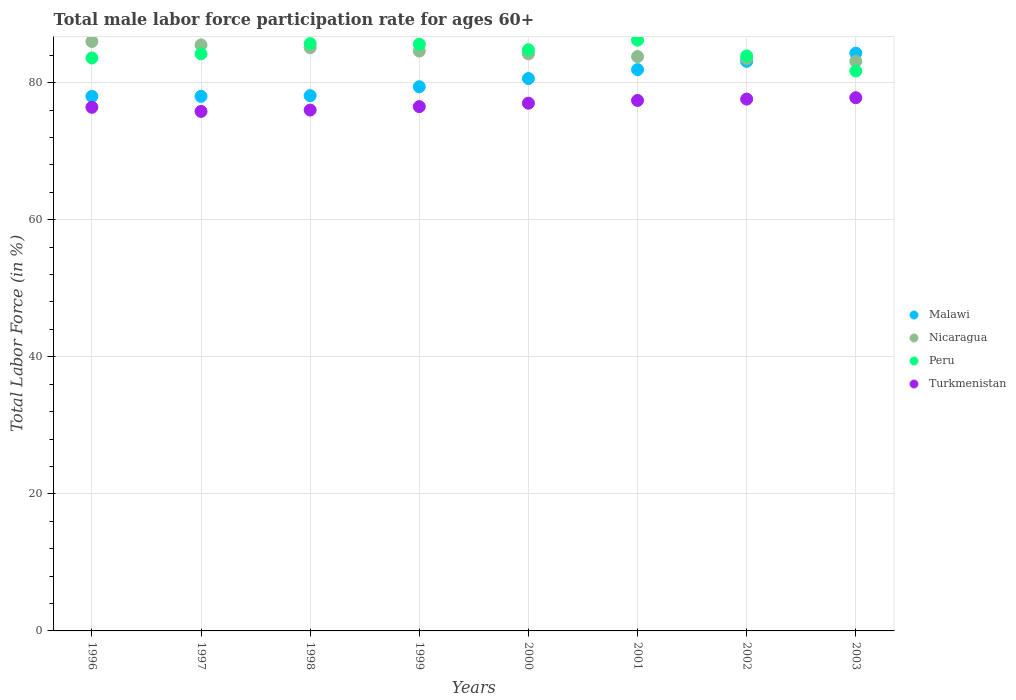How many different coloured dotlines are there?
Ensure brevity in your answer.  4. What is the male labor force participation rate in Peru in 2002?
Keep it short and to the point. 83.9. Across all years, what is the maximum male labor force participation rate in Peru?
Your answer should be compact. 86.2. Across all years, what is the minimum male labor force participation rate in Turkmenistan?
Ensure brevity in your answer.  75.8. What is the total male labor force participation rate in Malawi in the graph?
Your answer should be compact. 643.4. What is the difference between the male labor force participation rate in Malawi in 1999 and that in 2001?
Your response must be concise. -2.5. What is the difference between the male labor force participation rate in Malawi in 2003 and the male labor force participation rate in Turkmenistan in 1999?
Provide a short and direct response. 7.8. What is the average male labor force participation rate in Peru per year?
Offer a terse response. 84.46. In the year 1998, what is the difference between the male labor force participation rate in Turkmenistan and male labor force participation rate in Nicaragua?
Provide a short and direct response. -9.1. In how many years, is the male labor force participation rate in Malawi greater than 32 %?
Your answer should be compact. 8. What is the ratio of the male labor force participation rate in Malawi in 1998 to that in 2001?
Ensure brevity in your answer.  0.95. What is the difference between the highest and the second highest male labor force participation rate in Turkmenistan?
Give a very brief answer. 0.2. What is the difference between the highest and the lowest male labor force participation rate in Malawi?
Give a very brief answer. 6.3. In how many years, is the male labor force participation rate in Malawi greater than the average male labor force participation rate in Malawi taken over all years?
Offer a terse response. 4. Is the sum of the male labor force participation rate in Peru in 2000 and 2002 greater than the maximum male labor force participation rate in Nicaragua across all years?
Your response must be concise. Yes. Is it the case that in every year, the sum of the male labor force participation rate in Malawi and male labor force participation rate in Peru  is greater than the male labor force participation rate in Turkmenistan?
Ensure brevity in your answer.  Yes. Is the male labor force participation rate in Turkmenistan strictly less than the male labor force participation rate in Malawi over the years?
Your answer should be very brief. Yes. What is the difference between two consecutive major ticks on the Y-axis?
Your answer should be very brief. 20. Are the values on the major ticks of Y-axis written in scientific E-notation?
Your answer should be compact. No. Does the graph contain any zero values?
Ensure brevity in your answer.  No. Where does the legend appear in the graph?
Make the answer very short. Center right. How many legend labels are there?
Ensure brevity in your answer.  4. What is the title of the graph?
Make the answer very short. Total male labor force participation rate for ages 60+. Does "Luxembourg" appear as one of the legend labels in the graph?
Provide a succinct answer. No. What is the Total Labor Force (in %) of Malawi in 1996?
Make the answer very short. 78. What is the Total Labor Force (in %) of Peru in 1996?
Offer a terse response. 83.6. What is the Total Labor Force (in %) of Turkmenistan in 1996?
Make the answer very short. 76.4. What is the Total Labor Force (in %) in Nicaragua in 1997?
Your answer should be compact. 85.5. What is the Total Labor Force (in %) in Peru in 1997?
Ensure brevity in your answer.  84.2. What is the Total Labor Force (in %) of Turkmenistan in 1997?
Provide a succinct answer. 75.8. What is the Total Labor Force (in %) in Malawi in 1998?
Ensure brevity in your answer.  78.1. What is the Total Labor Force (in %) of Nicaragua in 1998?
Make the answer very short. 85.1. What is the Total Labor Force (in %) of Peru in 1998?
Offer a very short reply. 85.7. What is the Total Labor Force (in %) of Malawi in 1999?
Provide a succinct answer. 79.4. What is the Total Labor Force (in %) of Nicaragua in 1999?
Make the answer very short. 84.6. What is the Total Labor Force (in %) in Peru in 1999?
Provide a short and direct response. 85.6. What is the Total Labor Force (in %) of Turkmenistan in 1999?
Ensure brevity in your answer.  76.5. What is the Total Labor Force (in %) of Malawi in 2000?
Keep it short and to the point. 80.6. What is the Total Labor Force (in %) in Nicaragua in 2000?
Keep it short and to the point. 84.2. What is the Total Labor Force (in %) of Peru in 2000?
Give a very brief answer. 84.8. What is the Total Labor Force (in %) of Malawi in 2001?
Provide a succinct answer. 81.9. What is the Total Labor Force (in %) in Nicaragua in 2001?
Keep it short and to the point. 83.8. What is the Total Labor Force (in %) in Peru in 2001?
Offer a terse response. 86.2. What is the Total Labor Force (in %) of Turkmenistan in 2001?
Your response must be concise. 77.4. What is the Total Labor Force (in %) in Malawi in 2002?
Offer a very short reply. 83.1. What is the Total Labor Force (in %) in Nicaragua in 2002?
Give a very brief answer. 83.5. What is the Total Labor Force (in %) in Peru in 2002?
Provide a short and direct response. 83.9. What is the Total Labor Force (in %) of Turkmenistan in 2002?
Provide a short and direct response. 77.6. What is the Total Labor Force (in %) of Malawi in 2003?
Give a very brief answer. 84.3. What is the Total Labor Force (in %) of Nicaragua in 2003?
Ensure brevity in your answer.  83.1. What is the Total Labor Force (in %) of Peru in 2003?
Provide a succinct answer. 81.7. What is the Total Labor Force (in %) in Turkmenistan in 2003?
Your response must be concise. 77.8. Across all years, what is the maximum Total Labor Force (in %) in Malawi?
Offer a terse response. 84.3. Across all years, what is the maximum Total Labor Force (in %) in Nicaragua?
Offer a very short reply. 86. Across all years, what is the maximum Total Labor Force (in %) in Peru?
Your answer should be very brief. 86.2. Across all years, what is the maximum Total Labor Force (in %) of Turkmenistan?
Your response must be concise. 77.8. Across all years, what is the minimum Total Labor Force (in %) in Malawi?
Give a very brief answer. 78. Across all years, what is the minimum Total Labor Force (in %) in Nicaragua?
Make the answer very short. 83.1. Across all years, what is the minimum Total Labor Force (in %) of Peru?
Your answer should be compact. 81.7. Across all years, what is the minimum Total Labor Force (in %) in Turkmenistan?
Give a very brief answer. 75.8. What is the total Total Labor Force (in %) of Malawi in the graph?
Your response must be concise. 643.4. What is the total Total Labor Force (in %) of Nicaragua in the graph?
Give a very brief answer. 675.8. What is the total Total Labor Force (in %) in Peru in the graph?
Your response must be concise. 675.7. What is the total Total Labor Force (in %) in Turkmenistan in the graph?
Your response must be concise. 614.5. What is the difference between the Total Labor Force (in %) in Malawi in 1996 and that in 1998?
Ensure brevity in your answer.  -0.1. What is the difference between the Total Labor Force (in %) of Nicaragua in 1996 and that in 1998?
Your answer should be compact. 0.9. What is the difference between the Total Labor Force (in %) in Peru in 1996 and that in 1998?
Your response must be concise. -2.1. What is the difference between the Total Labor Force (in %) in Turkmenistan in 1996 and that in 1998?
Make the answer very short. 0.4. What is the difference between the Total Labor Force (in %) of Peru in 1996 and that in 1999?
Provide a succinct answer. -2. What is the difference between the Total Labor Force (in %) in Malawi in 1996 and that in 2000?
Provide a short and direct response. -2.6. What is the difference between the Total Labor Force (in %) of Nicaragua in 1996 and that in 2000?
Provide a succinct answer. 1.8. What is the difference between the Total Labor Force (in %) of Malawi in 1996 and that in 2001?
Give a very brief answer. -3.9. What is the difference between the Total Labor Force (in %) in Nicaragua in 1996 and that in 2001?
Your answer should be very brief. 2.2. What is the difference between the Total Labor Force (in %) of Peru in 1996 and that in 2001?
Provide a short and direct response. -2.6. What is the difference between the Total Labor Force (in %) in Malawi in 1996 and that in 2002?
Provide a short and direct response. -5.1. What is the difference between the Total Labor Force (in %) of Nicaragua in 1996 and that in 2002?
Make the answer very short. 2.5. What is the difference between the Total Labor Force (in %) in Malawi in 1996 and that in 2003?
Give a very brief answer. -6.3. What is the difference between the Total Labor Force (in %) of Peru in 1996 and that in 2003?
Your response must be concise. 1.9. What is the difference between the Total Labor Force (in %) in Turkmenistan in 1996 and that in 2003?
Your answer should be compact. -1.4. What is the difference between the Total Labor Force (in %) of Malawi in 1997 and that in 1998?
Offer a terse response. -0.1. What is the difference between the Total Labor Force (in %) of Nicaragua in 1997 and that in 1998?
Your answer should be very brief. 0.4. What is the difference between the Total Labor Force (in %) in Malawi in 1997 and that in 1999?
Ensure brevity in your answer.  -1.4. What is the difference between the Total Labor Force (in %) of Turkmenistan in 1997 and that in 1999?
Offer a very short reply. -0.7. What is the difference between the Total Labor Force (in %) in Peru in 1997 and that in 2000?
Provide a short and direct response. -0.6. What is the difference between the Total Labor Force (in %) of Malawi in 1997 and that in 2001?
Give a very brief answer. -3.9. What is the difference between the Total Labor Force (in %) of Turkmenistan in 1997 and that in 2001?
Offer a terse response. -1.6. What is the difference between the Total Labor Force (in %) in Malawi in 1997 and that in 2002?
Provide a short and direct response. -5.1. What is the difference between the Total Labor Force (in %) of Nicaragua in 1997 and that in 2002?
Your answer should be compact. 2. What is the difference between the Total Labor Force (in %) in Turkmenistan in 1997 and that in 2002?
Offer a terse response. -1.8. What is the difference between the Total Labor Force (in %) of Peru in 1997 and that in 2003?
Your answer should be compact. 2.5. What is the difference between the Total Labor Force (in %) of Malawi in 1998 and that in 1999?
Your response must be concise. -1.3. What is the difference between the Total Labor Force (in %) in Turkmenistan in 1998 and that in 1999?
Your answer should be compact. -0.5. What is the difference between the Total Labor Force (in %) of Malawi in 1998 and that in 2000?
Ensure brevity in your answer.  -2.5. What is the difference between the Total Labor Force (in %) of Nicaragua in 1998 and that in 2000?
Provide a succinct answer. 0.9. What is the difference between the Total Labor Force (in %) of Peru in 1998 and that in 2000?
Ensure brevity in your answer.  0.9. What is the difference between the Total Labor Force (in %) of Turkmenistan in 1998 and that in 2000?
Offer a very short reply. -1. What is the difference between the Total Labor Force (in %) in Nicaragua in 1998 and that in 2001?
Your answer should be very brief. 1.3. What is the difference between the Total Labor Force (in %) in Peru in 1998 and that in 2001?
Offer a very short reply. -0.5. What is the difference between the Total Labor Force (in %) in Nicaragua in 1998 and that in 2002?
Ensure brevity in your answer.  1.6. What is the difference between the Total Labor Force (in %) of Turkmenistan in 1998 and that in 2002?
Offer a terse response. -1.6. What is the difference between the Total Labor Force (in %) in Nicaragua in 1998 and that in 2003?
Give a very brief answer. 2. What is the difference between the Total Labor Force (in %) of Turkmenistan in 1998 and that in 2003?
Make the answer very short. -1.8. What is the difference between the Total Labor Force (in %) of Malawi in 1999 and that in 2000?
Make the answer very short. -1.2. What is the difference between the Total Labor Force (in %) in Peru in 1999 and that in 2000?
Ensure brevity in your answer.  0.8. What is the difference between the Total Labor Force (in %) in Malawi in 1999 and that in 2001?
Offer a very short reply. -2.5. What is the difference between the Total Labor Force (in %) of Malawi in 1999 and that in 2002?
Your response must be concise. -3.7. What is the difference between the Total Labor Force (in %) of Nicaragua in 1999 and that in 2002?
Your answer should be very brief. 1.1. What is the difference between the Total Labor Force (in %) in Peru in 1999 and that in 2002?
Give a very brief answer. 1.7. What is the difference between the Total Labor Force (in %) in Turkmenistan in 1999 and that in 2002?
Your answer should be very brief. -1.1. What is the difference between the Total Labor Force (in %) of Malawi in 1999 and that in 2003?
Ensure brevity in your answer.  -4.9. What is the difference between the Total Labor Force (in %) in Peru in 1999 and that in 2003?
Keep it short and to the point. 3.9. What is the difference between the Total Labor Force (in %) in Nicaragua in 2000 and that in 2001?
Keep it short and to the point. 0.4. What is the difference between the Total Labor Force (in %) in Peru in 2000 and that in 2001?
Keep it short and to the point. -1.4. What is the difference between the Total Labor Force (in %) of Malawi in 2000 and that in 2002?
Your answer should be very brief. -2.5. What is the difference between the Total Labor Force (in %) of Nicaragua in 2000 and that in 2002?
Your response must be concise. 0.7. What is the difference between the Total Labor Force (in %) of Turkmenistan in 2000 and that in 2002?
Provide a short and direct response. -0.6. What is the difference between the Total Labor Force (in %) of Nicaragua in 2000 and that in 2003?
Your response must be concise. 1.1. What is the difference between the Total Labor Force (in %) in Peru in 2001 and that in 2002?
Provide a succinct answer. 2.3. What is the difference between the Total Labor Force (in %) in Turkmenistan in 2001 and that in 2002?
Provide a short and direct response. -0.2. What is the difference between the Total Labor Force (in %) in Malawi in 2001 and that in 2003?
Provide a succinct answer. -2.4. What is the difference between the Total Labor Force (in %) of Turkmenistan in 2001 and that in 2003?
Offer a terse response. -0.4. What is the difference between the Total Labor Force (in %) of Malawi in 2002 and that in 2003?
Offer a very short reply. -1.2. What is the difference between the Total Labor Force (in %) of Turkmenistan in 2002 and that in 2003?
Make the answer very short. -0.2. What is the difference between the Total Labor Force (in %) in Nicaragua in 1996 and the Total Labor Force (in %) in Peru in 1997?
Keep it short and to the point. 1.8. What is the difference between the Total Labor Force (in %) in Malawi in 1996 and the Total Labor Force (in %) in Nicaragua in 1998?
Provide a succinct answer. -7.1. What is the difference between the Total Labor Force (in %) of Malawi in 1996 and the Total Labor Force (in %) of Peru in 1998?
Your response must be concise. -7.7. What is the difference between the Total Labor Force (in %) of Nicaragua in 1996 and the Total Labor Force (in %) of Turkmenistan in 1998?
Offer a terse response. 10. What is the difference between the Total Labor Force (in %) of Peru in 1996 and the Total Labor Force (in %) of Turkmenistan in 1998?
Offer a terse response. 7.6. What is the difference between the Total Labor Force (in %) in Malawi in 1996 and the Total Labor Force (in %) in Nicaragua in 1999?
Offer a terse response. -6.6. What is the difference between the Total Labor Force (in %) in Malawi in 1996 and the Total Labor Force (in %) in Peru in 1999?
Give a very brief answer. -7.6. What is the difference between the Total Labor Force (in %) of Malawi in 1996 and the Total Labor Force (in %) of Turkmenistan in 1999?
Make the answer very short. 1.5. What is the difference between the Total Labor Force (in %) of Nicaragua in 1996 and the Total Labor Force (in %) of Peru in 1999?
Provide a succinct answer. 0.4. What is the difference between the Total Labor Force (in %) of Malawi in 1996 and the Total Labor Force (in %) of Turkmenistan in 2000?
Your response must be concise. 1. What is the difference between the Total Labor Force (in %) in Nicaragua in 1996 and the Total Labor Force (in %) in Peru in 2000?
Keep it short and to the point. 1.2. What is the difference between the Total Labor Force (in %) in Malawi in 1996 and the Total Labor Force (in %) in Peru in 2001?
Offer a very short reply. -8.2. What is the difference between the Total Labor Force (in %) in Malawi in 1996 and the Total Labor Force (in %) in Turkmenistan in 2001?
Your answer should be compact. 0.6. What is the difference between the Total Labor Force (in %) in Nicaragua in 1996 and the Total Labor Force (in %) in Peru in 2001?
Keep it short and to the point. -0.2. What is the difference between the Total Labor Force (in %) of Malawi in 1996 and the Total Labor Force (in %) of Nicaragua in 2002?
Keep it short and to the point. -5.5. What is the difference between the Total Labor Force (in %) of Nicaragua in 1996 and the Total Labor Force (in %) of Peru in 2002?
Ensure brevity in your answer.  2.1. What is the difference between the Total Labor Force (in %) in Nicaragua in 1996 and the Total Labor Force (in %) in Turkmenistan in 2002?
Your response must be concise. 8.4. What is the difference between the Total Labor Force (in %) in Peru in 1996 and the Total Labor Force (in %) in Turkmenistan in 2002?
Provide a succinct answer. 6. What is the difference between the Total Labor Force (in %) in Malawi in 1996 and the Total Labor Force (in %) in Peru in 2003?
Your answer should be compact. -3.7. What is the difference between the Total Labor Force (in %) of Malawi in 1996 and the Total Labor Force (in %) of Turkmenistan in 2003?
Provide a short and direct response. 0.2. What is the difference between the Total Labor Force (in %) of Peru in 1996 and the Total Labor Force (in %) of Turkmenistan in 2003?
Provide a short and direct response. 5.8. What is the difference between the Total Labor Force (in %) in Nicaragua in 1997 and the Total Labor Force (in %) in Turkmenistan in 1998?
Ensure brevity in your answer.  9.5. What is the difference between the Total Labor Force (in %) in Malawi in 1997 and the Total Labor Force (in %) in Nicaragua in 1999?
Give a very brief answer. -6.6. What is the difference between the Total Labor Force (in %) in Malawi in 1997 and the Total Labor Force (in %) in Turkmenistan in 1999?
Provide a short and direct response. 1.5. What is the difference between the Total Labor Force (in %) in Malawi in 1997 and the Total Labor Force (in %) in Nicaragua in 2000?
Keep it short and to the point. -6.2. What is the difference between the Total Labor Force (in %) in Nicaragua in 1997 and the Total Labor Force (in %) in Turkmenistan in 2000?
Provide a succinct answer. 8.5. What is the difference between the Total Labor Force (in %) in Peru in 1997 and the Total Labor Force (in %) in Turkmenistan in 2001?
Ensure brevity in your answer.  6.8. What is the difference between the Total Labor Force (in %) in Malawi in 1997 and the Total Labor Force (in %) in Nicaragua in 2002?
Make the answer very short. -5.5. What is the difference between the Total Labor Force (in %) in Malawi in 1997 and the Total Labor Force (in %) in Peru in 2002?
Offer a terse response. -5.9. What is the difference between the Total Labor Force (in %) of Malawi in 1997 and the Total Labor Force (in %) of Turkmenistan in 2002?
Your response must be concise. 0.4. What is the difference between the Total Labor Force (in %) of Peru in 1997 and the Total Labor Force (in %) of Turkmenistan in 2002?
Keep it short and to the point. 6.6. What is the difference between the Total Labor Force (in %) in Malawi in 1997 and the Total Labor Force (in %) in Nicaragua in 2003?
Your answer should be compact. -5.1. What is the difference between the Total Labor Force (in %) of Malawi in 1997 and the Total Labor Force (in %) of Turkmenistan in 2003?
Offer a terse response. 0.2. What is the difference between the Total Labor Force (in %) of Peru in 1997 and the Total Labor Force (in %) of Turkmenistan in 2003?
Make the answer very short. 6.4. What is the difference between the Total Labor Force (in %) of Malawi in 1998 and the Total Labor Force (in %) of Nicaragua in 1999?
Provide a short and direct response. -6.5. What is the difference between the Total Labor Force (in %) of Malawi in 1998 and the Total Labor Force (in %) of Peru in 1999?
Make the answer very short. -7.5. What is the difference between the Total Labor Force (in %) in Nicaragua in 1998 and the Total Labor Force (in %) in Peru in 1999?
Your answer should be compact. -0.5. What is the difference between the Total Labor Force (in %) of Nicaragua in 1998 and the Total Labor Force (in %) of Turkmenistan in 1999?
Keep it short and to the point. 8.6. What is the difference between the Total Labor Force (in %) in Peru in 1998 and the Total Labor Force (in %) in Turkmenistan in 1999?
Give a very brief answer. 9.2. What is the difference between the Total Labor Force (in %) of Nicaragua in 1998 and the Total Labor Force (in %) of Turkmenistan in 2000?
Keep it short and to the point. 8.1. What is the difference between the Total Labor Force (in %) in Malawi in 1998 and the Total Labor Force (in %) in Nicaragua in 2001?
Offer a terse response. -5.7. What is the difference between the Total Labor Force (in %) in Nicaragua in 1998 and the Total Labor Force (in %) in Peru in 2001?
Offer a terse response. -1.1. What is the difference between the Total Labor Force (in %) of Peru in 1998 and the Total Labor Force (in %) of Turkmenistan in 2001?
Give a very brief answer. 8.3. What is the difference between the Total Labor Force (in %) in Nicaragua in 1998 and the Total Labor Force (in %) in Peru in 2002?
Offer a terse response. 1.2. What is the difference between the Total Labor Force (in %) of Malawi in 1998 and the Total Labor Force (in %) of Turkmenistan in 2003?
Make the answer very short. 0.3. What is the difference between the Total Labor Force (in %) in Nicaragua in 1998 and the Total Labor Force (in %) in Turkmenistan in 2003?
Give a very brief answer. 7.3. What is the difference between the Total Labor Force (in %) in Malawi in 1999 and the Total Labor Force (in %) in Nicaragua in 2000?
Your answer should be compact. -4.8. What is the difference between the Total Labor Force (in %) in Malawi in 1999 and the Total Labor Force (in %) in Peru in 2000?
Your response must be concise. -5.4. What is the difference between the Total Labor Force (in %) of Nicaragua in 1999 and the Total Labor Force (in %) of Turkmenistan in 2000?
Offer a very short reply. 7.6. What is the difference between the Total Labor Force (in %) in Peru in 1999 and the Total Labor Force (in %) in Turkmenistan in 2000?
Your answer should be compact. 8.6. What is the difference between the Total Labor Force (in %) of Malawi in 1999 and the Total Labor Force (in %) of Peru in 2001?
Keep it short and to the point. -6.8. What is the difference between the Total Labor Force (in %) in Nicaragua in 1999 and the Total Labor Force (in %) in Peru in 2001?
Provide a short and direct response. -1.6. What is the difference between the Total Labor Force (in %) of Malawi in 1999 and the Total Labor Force (in %) of Nicaragua in 2003?
Your answer should be very brief. -3.7. What is the difference between the Total Labor Force (in %) in Malawi in 1999 and the Total Labor Force (in %) in Peru in 2003?
Your answer should be very brief. -2.3. What is the difference between the Total Labor Force (in %) of Malawi in 1999 and the Total Labor Force (in %) of Turkmenistan in 2003?
Your answer should be compact. 1.6. What is the difference between the Total Labor Force (in %) of Nicaragua in 1999 and the Total Labor Force (in %) of Peru in 2003?
Offer a terse response. 2.9. What is the difference between the Total Labor Force (in %) of Nicaragua in 1999 and the Total Labor Force (in %) of Turkmenistan in 2003?
Offer a very short reply. 6.8. What is the difference between the Total Labor Force (in %) in Peru in 1999 and the Total Labor Force (in %) in Turkmenistan in 2003?
Provide a succinct answer. 7.8. What is the difference between the Total Labor Force (in %) in Malawi in 2000 and the Total Labor Force (in %) in Nicaragua in 2001?
Your answer should be compact. -3.2. What is the difference between the Total Labor Force (in %) in Malawi in 2000 and the Total Labor Force (in %) in Turkmenistan in 2001?
Provide a succinct answer. 3.2. What is the difference between the Total Labor Force (in %) of Malawi in 2000 and the Total Labor Force (in %) of Peru in 2002?
Give a very brief answer. -3.3. What is the difference between the Total Labor Force (in %) in Nicaragua in 2000 and the Total Labor Force (in %) in Peru in 2002?
Keep it short and to the point. 0.3. What is the difference between the Total Labor Force (in %) in Nicaragua in 2000 and the Total Labor Force (in %) in Peru in 2003?
Your response must be concise. 2.5. What is the difference between the Total Labor Force (in %) in Peru in 2000 and the Total Labor Force (in %) in Turkmenistan in 2003?
Offer a very short reply. 7. What is the difference between the Total Labor Force (in %) of Malawi in 2001 and the Total Labor Force (in %) of Peru in 2002?
Make the answer very short. -2. What is the difference between the Total Labor Force (in %) in Malawi in 2001 and the Total Labor Force (in %) in Turkmenistan in 2002?
Provide a short and direct response. 4.3. What is the difference between the Total Labor Force (in %) in Peru in 2001 and the Total Labor Force (in %) in Turkmenistan in 2002?
Make the answer very short. 8.6. What is the difference between the Total Labor Force (in %) in Malawi in 2002 and the Total Labor Force (in %) in Nicaragua in 2003?
Your response must be concise. 0. What is the difference between the Total Labor Force (in %) of Peru in 2002 and the Total Labor Force (in %) of Turkmenistan in 2003?
Your answer should be compact. 6.1. What is the average Total Labor Force (in %) of Malawi per year?
Your response must be concise. 80.42. What is the average Total Labor Force (in %) in Nicaragua per year?
Offer a very short reply. 84.47. What is the average Total Labor Force (in %) of Peru per year?
Give a very brief answer. 84.46. What is the average Total Labor Force (in %) in Turkmenistan per year?
Keep it short and to the point. 76.81. In the year 1996, what is the difference between the Total Labor Force (in %) in Malawi and Total Labor Force (in %) in Peru?
Offer a terse response. -5.6. In the year 1996, what is the difference between the Total Labor Force (in %) in Nicaragua and Total Labor Force (in %) in Peru?
Offer a very short reply. 2.4. In the year 1996, what is the difference between the Total Labor Force (in %) of Nicaragua and Total Labor Force (in %) of Turkmenistan?
Offer a terse response. 9.6. In the year 1997, what is the difference between the Total Labor Force (in %) of Malawi and Total Labor Force (in %) of Nicaragua?
Give a very brief answer. -7.5. In the year 1997, what is the difference between the Total Labor Force (in %) in Malawi and Total Labor Force (in %) in Turkmenistan?
Offer a very short reply. 2.2. In the year 1997, what is the difference between the Total Labor Force (in %) of Nicaragua and Total Labor Force (in %) of Turkmenistan?
Offer a very short reply. 9.7. In the year 1997, what is the difference between the Total Labor Force (in %) in Peru and Total Labor Force (in %) in Turkmenistan?
Offer a terse response. 8.4. In the year 1998, what is the difference between the Total Labor Force (in %) of Malawi and Total Labor Force (in %) of Nicaragua?
Provide a short and direct response. -7. In the year 1998, what is the difference between the Total Labor Force (in %) of Malawi and Total Labor Force (in %) of Peru?
Your response must be concise. -7.6. In the year 1998, what is the difference between the Total Labor Force (in %) in Malawi and Total Labor Force (in %) in Turkmenistan?
Keep it short and to the point. 2.1. In the year 1998, what is the difference between the Total Labor Force (in %) of Nicaragua and Total Labor Force (in %) of Peru?
Offer a very short reply. -0.6. In the year 1999, what is the difference between the Total Labor Force (in %) in Malawi and Total Labor Force (in %) in Turkmenistan?
Make the answer very short. 2.9. In the year 1999, what is the difference between the Total Labor Force (in %) of Nicaragua and Total Labor Force (in %) of Peru?
Offer a very short reply. -1. In the year 2000, what is the difference between the Total Labor Force (in %) of Malawi and Total Labor Force (in %) of Peru?
Provide a succinct answer. -4.2. In the year 2000, what is the difference between the Total Labor Force (in %) in Nicaragua and Total Labor Force (in %) in Peru?
Make the answer very short. -0.6. In the year 2001, what is the difference between the Total Labor Force (in %) in Malawi and Total Labor Force (in %) in Peru?
Your response must be concise. -4.3. In the year 2001, what is the difference between the Total Labor Force (in %) in Nicaragua and Total Labor Force (in %) in Turkmenistan?
Keep it short and to the point. 6.4. In the year 2002, what is the difference between the Total Labor Force (in %) in Malawi and Total Labor Force (in %) in Peru?
Give a very brief answer. -0.8. In the year 2002, what is the difference between the Total Labor Force (in %) in Peru and Total Labor Force (in %) in Turkmenistan?
Give a very brief answer. 6.3. In the year 2003, what is the difference between the Total Labor Force (in %) of Malawi and Total Labor Force (in %) of Peru?
Ensure brevity in your answer.  2.6. In the year 2003, what is the difference between the Total Labor Force (in %) in Peru and Total Labor Force (in %) in Turkmenistan?
Your response must be concise. 3.9. What is the ratio of the Total Labor Force (in %) in Peru in 1996 to that in 1997?
Your response must be concise. 0.99. What is the ratio of the Total Labor Force (in %) in Turkmenistan in 1996 to that in 1997?
Your answer should be compact. 1.01. What is the ratio of the Total Labor Force (in %) in Nicaragua in 1996 to that in 1998?
Offer a very short reply. 1.01. What is the ratio of the Total Labor Force (in %) in Peru in 1996 to that in 1998?
Provide a succinct answer. 0.98. What is the ratio of the Total Labor Force (in %) of Turkmenistan in 1996 to that in 1998?
Give a very brief answer. 1.01. What is the ratio of the Total Labor Force (in %) in Malawi in 1996 to that in 1999?
Make the answer very short. 0.98. What is the ratio of the Total Labor Force (in %) in Nicaragua in 1996 to that in 1999?
Provide a short and direct response. 1.02. What is the ratio of the Total Labor Force (in %) in Peru in 1996 to that in 1999?
Your answer should be very brief. 0.98. What is the ratio of the Total Labor Force (in %) of Nicaragua in 1996 to that in 2000?
Your answer should be very brief. 1.02. What is the ratio of the Total Labor Force (in %) of Peru in 1996 to that in 2000?
Your answer should be very brief. 0.99. What is the ratio of the Total Labor Force (in %) of Malawi in 1996 to that in 2001?
Make the answer very short. 0.95. What is the ratio of the Total Labor Force (in %) in Nicaragua in 1996 to that in 2001?
Provide a succinct answer. 1.03. What is the ratio of the Total Labor Force (in %) of Peru in 1996 to that in 2001?
Ensure brevity in your answer.  0.97. What is the ratio of the Total Labor Force (in %) of Turkmenistan in 1996 to that in 2001?
Offer a terse response. 0.99. What is the ratio of the Total Labor Force (in %) in Malawi in 1996 to that in 2002?
Provide a succinct answer. 0.94. What is the ratio of the Total Labor Force (in %) in Nicaragua in 1996 to that in 2002?
Your answer should be compact. 1.03. What is the ratio of the Total Labor Force (in %) of Peru in 1996 to that in 2002?
Your answer should be compact. 1. What is the ratio of the Total Labor Force (in %) of Turkmenistan in 1996 to that in 2002?
Keep it short and to the point. 0.98. What is the ratio of the Total Labor Force (in %) of Malawi in 1996 to that in 2003?
Your answer should be very brief. 0.93. What is the ratio of the Total Labor Force (in %) of Nicaragua in 1996 to that in 2003?
Your response must be concise. 1.03. What is the ratio of the Total Labor Force (in %) of Peru in 1996 to that in 2003?
Make the answer very short. 1.02. What is the ratio of the Total Labor Force (in %) in Malawi in 1997 to that in 1998?
Provide a short and direct response. 1. What is the ratio of the Total Labor Force (in %) in Peru in 1997 to that in 1998?
Provide a succinct answer. 0.98. What is the ratio of the Total Labor Force (in %) of Malawi in 1997 to that in 1999?
Provide a short and direct response. 0.98. What is the ratio of the Total Labor Force (in %) in Nicaragua in 1997 to that in 1999?
Offer a terse response. 1.01. What is the ratio of the Total Labor Force (in %) in Peru in 1997 to that in 1999?
Your response must be concise. 0.98. What is the ratio of the Total Labor Force (in %) in Turkmenistan in 1997 to that in 1999?
Your answer should be very brief. 0.99. What is the ratio of the Total Labor Force (in %) of Nicaragua in 1997 to that in 2000?
Make the answer very short. 1.02. What is the ratio of the Total Labor Force (in %) of Peru in 1997 to that in 2000?
Give a very brief answer. 0.99. What is the ratio of the Total Labor Force (in %) of Turkmenistan in 1997 to that in 2000?
Offer a terse response. 0.98. What is the ratio of the Total Labor Force (in %) in Nicaragua in 1997 to that in 2001?
Ensure brevity in your answer.  1.02. What is the ratio of the Total Labor Force (in %) of Peru in 1997 to that in 2001?
Provide a short and direct response. 0.98. What is the ratio of the Total Labor Force (in %) in Turkmenistan in 1997 to that in 2001?
Keep it short and to the point. 0.98. What is the ratio of the Total Labor Force (in %) in Malawi in 1997 to that in 2002?
Give a very brief answer. 0.94. What is the ratio of the Total Labor Force (in %) of Nicaragua in 1997 to that in 2002?
Make the answer very short. 1.02. What is the ratio of the Total Labor Force (in %) of Turkmenistan in 1997 to that in 2002?
Ensure brevity in your answer.  0.98. What is the ratio of the Total Labor Force (in %) in Malawi in 1997 to that in 2003?
Your answer should be very brief. 0.93. What is the ratio of the Total Labor Force (in %) of Nicaragua in 1997 to that in 2003?
Offer a terse response. 1.03. What is the ratio of the Total Labor Force (in %) in Peru in 1997 to that in 2003?
Keep it short and to the point. 1.03. What is the ratio of the Total Labor Force (in %) in Turkmenistan in 1997 to that in 2003?
Ensure brevity in your answer.  0.97. What is the ratio of the Total Labor Force (in %) in Malawi in 1998 to that in 1999?
Provide a short and direct response. 0.98. What is the ratio of the Total Labor Force (in %) of Nicaragua in 1998 to that in 1999?
Keep it short and to the point. 1.01. What is the ratio of the Total Labor Force (in %) of Turkmenistan in 1998 to that in 1999?
Ensure brevity in your answer.  0.99. What is the ratio of the Total Labor Force (in %) of Nicaragua in 1998 to that in 2000?
Your answer should be compact. 1.01. What is the ratio of the Total Labor Force (in %) of Peru in 1998 to that in 2000?
Make the answer very short. 1.01. What is the ratio of the Total Labor Force (in %) of Malawi in 1998 to that in 2001?
Keep it short and to the point. 0.95. What is the ratio of the Total Labor Force (in %) in Nicaragua in 1998 to that in 2001?
Make the answer very short. 1.02. What is the ratio of the Total Labor Force (in %) of Peru in 1998 to that in 2001?
Give a very brief answer. 0.99. What is the ratio of the Total Labor Force (in %) of Turkmenistan in 1998 to that in 2001?
Your answer should be compact. 0.98. What is the ratio of the Total Labor Force (in %) of Malawi in 1998 to that in 2002?
Your answer should be very brief. 0.94. What is the ratio of the Total Labor Force (in %) of Nicaragua in 1998 to that in 2002?
Your response must be concise. 1.02. What is the ratio of the Total Labor Force (in %) of Peru in 1998 to that in 2002?
Your answer should be compact. 1.02. What is the ratio of the Total Labor Force (in %) of Turkmenistan in 1998 to that in 2002?
Give a very brief answer. 0.98. What is the ratio of the Total Labor Force (in %) of Malawi in 1998 to that in 2003?
Make the answer very short. 0.93. What is the ratio of the Total Labor Force (in %) of Nicaragua in 1998 to that in 2003?
Provide a succinct answer. 1.02. What is the ratio of the Total Labor Force (in %) of Peru in 1998 to that in 2003?
Keep it short and to the point. 1.05. What is the ratio of the Total Labor Force (in %) in Turkmenistan in 1998 to that in 2003?
Ensure brevity in your answer.  0.98. What is the ratio of the Total Labor Force (in %) in Malawi in 1999 to that in 2000?
Offer a very short reply. 0.99. What is the ratio of the Total Labor Force (in %) of Peru in 1999 to that in 2000?
Your answer should be very brief. 1.01. What is the ratio of the Total Labor Force (in %) of Turkmenistan in 1999 to that in 2000?
Give a very brief answer. 0.99. What is the ratio of the Total Labor Force (in %) in Malawi in 1999 to that in 2001?
Your response must be concise. 0.97. What is the ratio of the Total Labor Force (in %) of Nicaragua in 1999 to that in 2001?
Your answer should be very brief. 1.01. What is the ratio of the Total Labor Force (in %) in Peru in 1999 to that in 2001?
Give a very brief answer. 0.99. What is the ratio of the Total Labor Force (in %) in Turkmenistan in 1999 to that in 2001?
Make the answer very short. 0.99. What is the ratio of the Total Labor Force (in %) in Malawi in 1999 to that in 2002?
Your answer should be very brief. 0.96. What is the ratio of the Total Labor Force (in %) in Nicaragua in 1999 to that in 2002?
Give a very brief answer. 1.01. What is the ratio of the Total Labor Force (in %) in Peru in 1999 to that in 2002?
Keep it short and to the point. 1.02. What is the ratio of the Total Labor Force (in %) of Turkmenistan in 1999 to that in 2002?
Offer a terse response. 0.99. What is the ratio of the Total Labor Force (in %) in Malawi in 1999 to that in 2003?
Offer a terse response. 0.94. What is the ratio of the Total Labor Force (in %) in Nicaragua in 1999 to that in 2003?
Offer a very short reply. 1.02. What is the ratio of the Total Labor Force (in %) in Peru in 1999 to that in 2003?
Your answer should be very brief. 1.05. What is the ratio of the Total Labor Force (in %) of Turkmenistan in 1999 to that in 2003?
Provide a short and direct response. 0.98. What is the ratio of the Total Labor Force (in %) in Malawi in 2000 to that in 2001?
Provide a short and direct response. 0.98. What is the ratio of the Total Labor Force (in %) in Peru in 2000 to that in 2001?
Offer a very short reply. 0.98. What is the ratio of the Total Labor Force (in %) of Malawi in 2000 to that in 2002?
Your response must be concise. 0.97. What is the ratio of the Total Labor Force (in %) of Nicaragua in 2000 to that in 2002?
Your answer should be very brief. 1.01. What is the ratio of the Total Labor Force (in %) of Peru in 2000 to that in 2002?
Give a very brief answer. 1.01. What is the ratio of the Total Labor Force (in %) in Turkmenistan in 2000 to that in 2002?
Provide a short and direct response. 0.99. What is the ratio of the Total Labor Force (in %) in Malawi in 2000 to that in 2003?
Provide a succinct answer. 0.96. What is the ratio of the Total Labor Force (in %) in Nicaragua in 2000 to that in 2003?
Keep it short and to the point. 1.01. What is the ratio of the Total Labor Force (in %) in Peru in 2000 to that in 2003?
Offer a terse response. 1.04. What is the ratio of the Total Labor Force (in %) of Turkmenistan in 2000 to that in 2003?
Keep it short and to the point. 0.99. What is the ratio of the Total Labor Force (in %) of Malawi in 2001 to that in 2002?
Provide a succinct answer. 0.99. What is the ratio of the Total Labor Force (in %) in Peru in 2001 to that in 2002?
Give a very brief answer. 1.03. What is the ratio of the Total Labor Force (in %) in Turkmenistan in 2001 to that in 2002?
Keep it short and to the point. 1. What is the ratio of the Total Labor Force (in %) of Malawi in 2001 to that in 2003?
Ensure brevity in your answer.  0.97. What is the ratio of the Total Labor Force (in %) in Nicaragua in 2001 to that in 2003?
Offer a very short reply. 1.01. What is the ratio of the Total Labor Force (in %) in Peru in 2001 to that in 2003?
Your answer should be very brief. 1.06. What is the ratio of the Total Labor Force (in %) in Turkmenistan in 2001 to that in 2003?
Make the answer very short. 0.99. What is the ratio of the Total Labor Force (in %) of Malawi in 2002 to that in 2003?
Ensure brevity in your answer.  0.99. What is the ratio of the Total Labor Force (in %) in Peru in 2002 to that in 2003?
Give a very brief answer. 1.03. What is the ratio of the Total Labor Force (in %) in Turkmenistan in 2002 to that in 2003?
Give a very brief answer. 1. What is the difference between the highest and the second highest Total Labor Force (in %) of Malawi?
Your response must be concise. 1.2. What is the difference between the highest and the second highest Total Labor Force (in %) in Peru?
Offer a terse response. 0.5. What is the difference between the highest and the second highest Total Labor Force (in %) of Turkmenistan?
Ensure brevity in your answer.  0.2. What is the difference between the highest and the lowest Total Labor Force (in %) in Nicaragua?
Your answer should be very brief. 2.9. What is the difference between the highest and the lowest Total Labor Force (in %) of Peru?
Your response must be concise. 4.5. What is the difference between the highest and the lowest Total Labor Force (in %) in Turkmenistan?
Your answer should be compact. 2. 